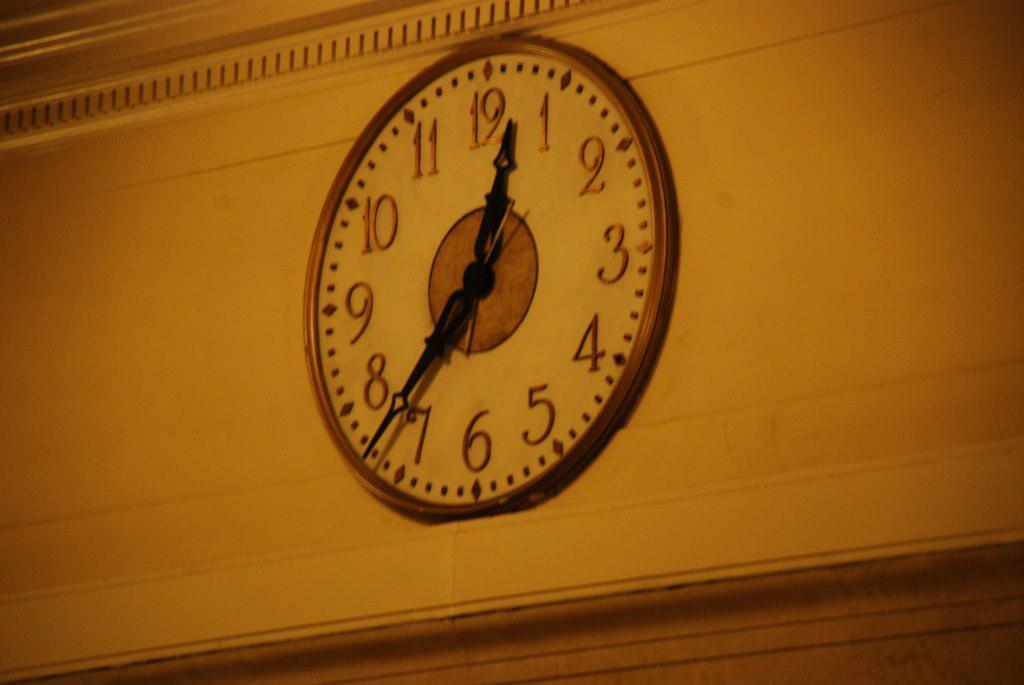<image>
Present a compact description of the photo's key features. Clock which has the hands on the number 12 and 7. 